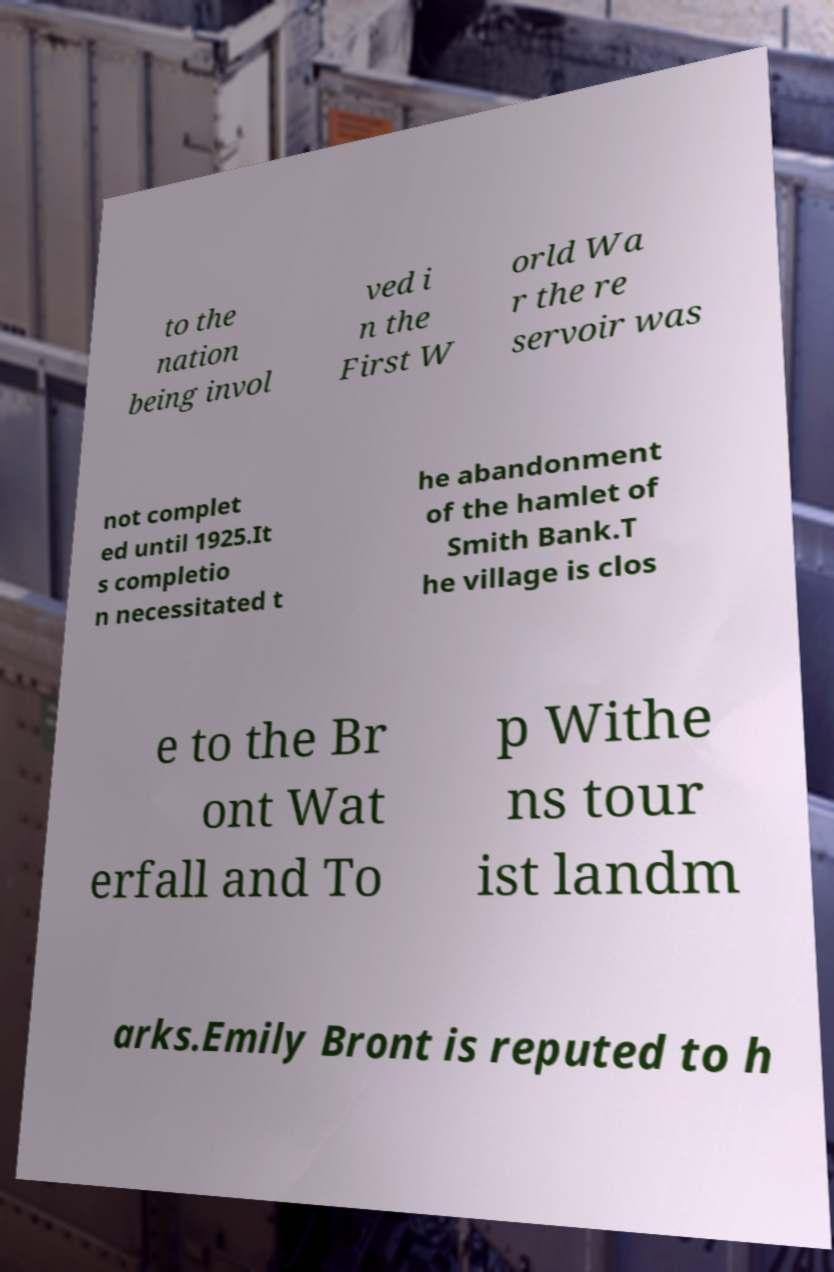Please read and relay the text visible in this image. What does it say? to the nation being invol ved i n the First W orld Wa r the re servoir was not complet ed until 1925.It s completio n necessitated t he abandonment of the hamlet of Smith Bank.T he village is clos e to the Br ont Wat erfall and To p Withe ns tour ist landm arks.Emily Bront is reputed to h 